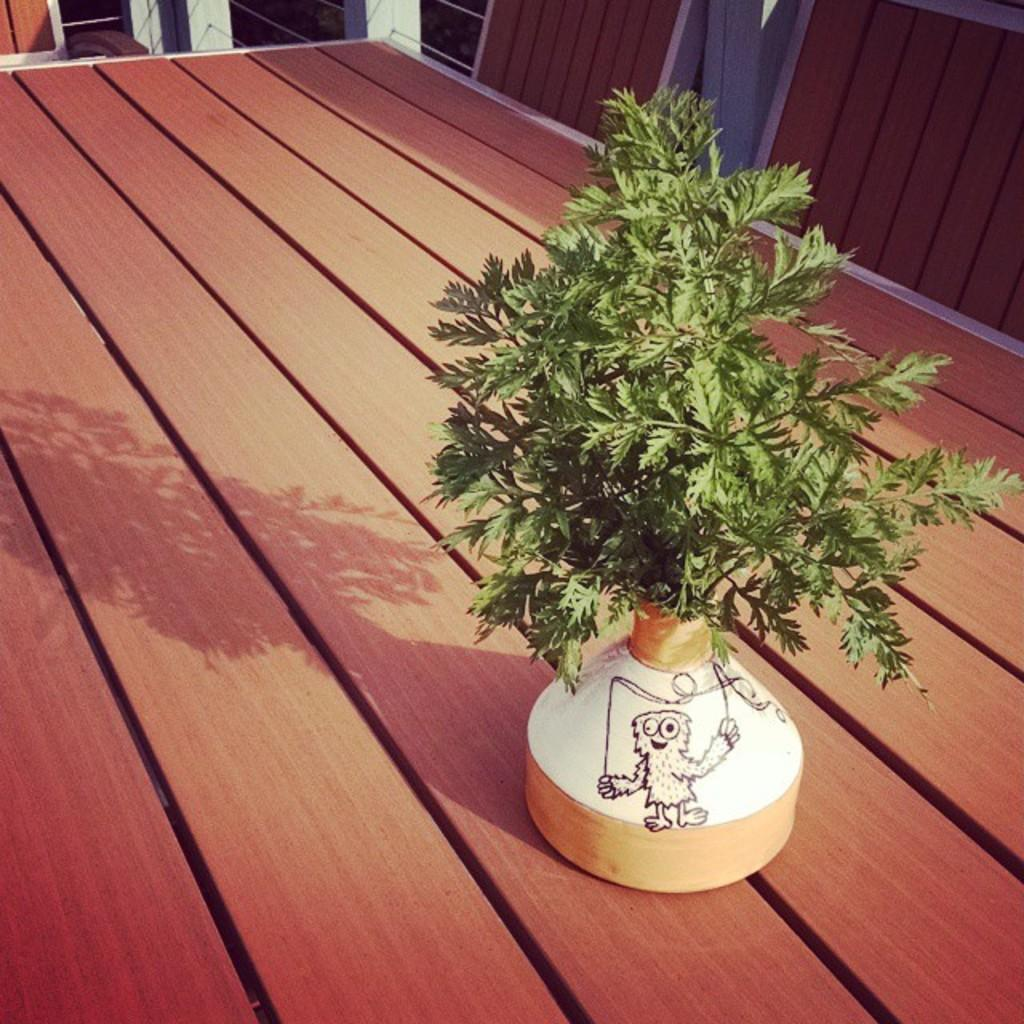What type of plant is in the image? There is a houseplant in the image. Where is the houseplant located? The houseplant is on the wooden floor. What type of acoustics can be heard from the houseplant in the image? There is no sound or acoustics associated with the houseplant in the image. 